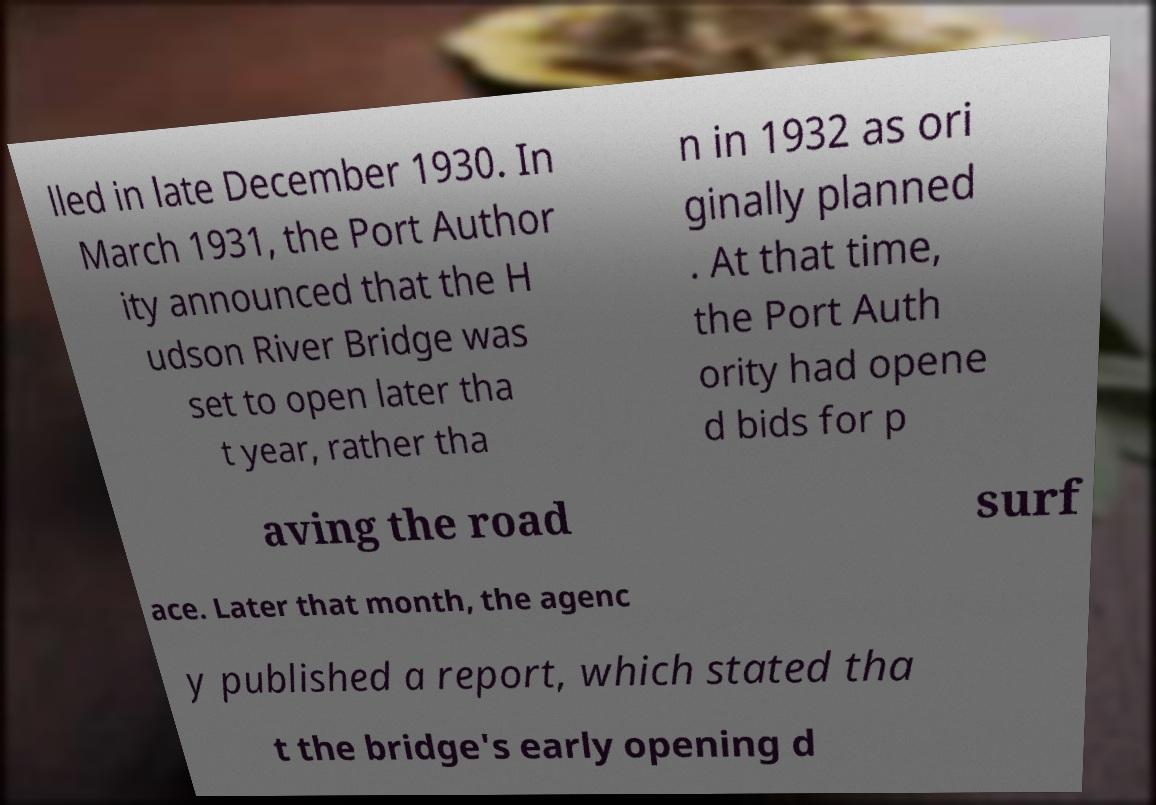Could you assist in decoding the text presented in this image and type it out clearly? lled in late December 1930. In March 1931, the Port Author ity announced that the H udson River Bridge was set to open later tha t year, rather tha n in 1932 as ori ginally planned . At that time, the Port Auth ority had opene d bids for p aving the road surf ace. Later that month, the agenc y published a report, which stated tha t the bridge's early opening d 